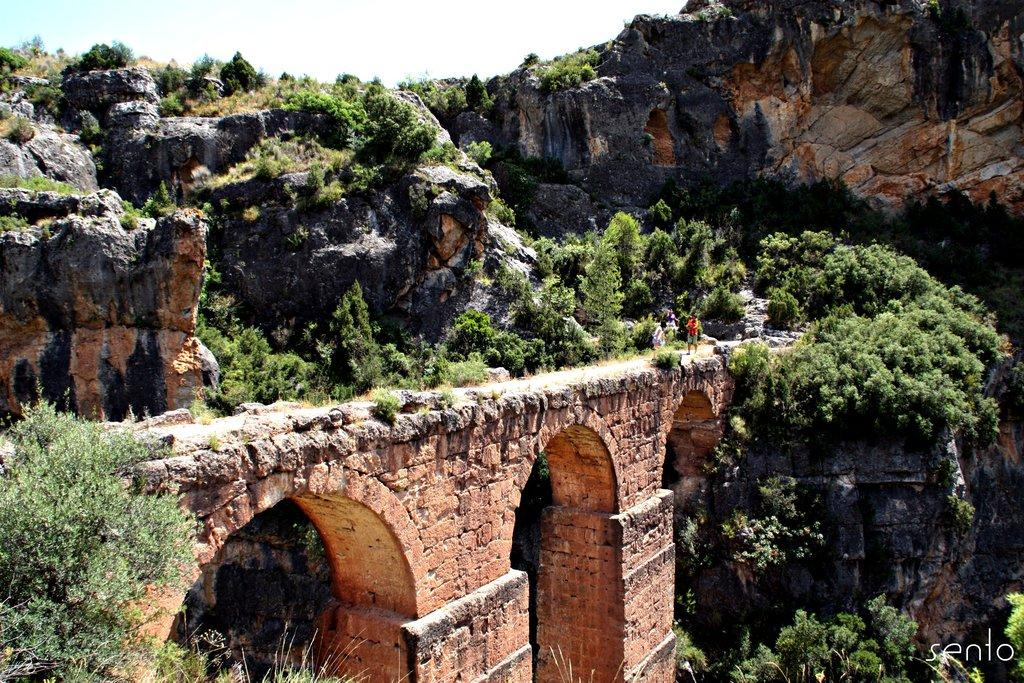What type of structure can be seen in the image? There is a bridge in the image. Are there any people present in the image? Yes, there are persons in the image. What other natural elements can be seen in the image? There are plants and mountains in the image. What is visible in the background of the image? The sky is visible in the background of the image. What type of maid can be seen in the image? There is no maid present in the image. Can you describe the self-awareness of the persons in the image? The persons in the image do not exhibit self-awareness, as they are not sentient beings. 